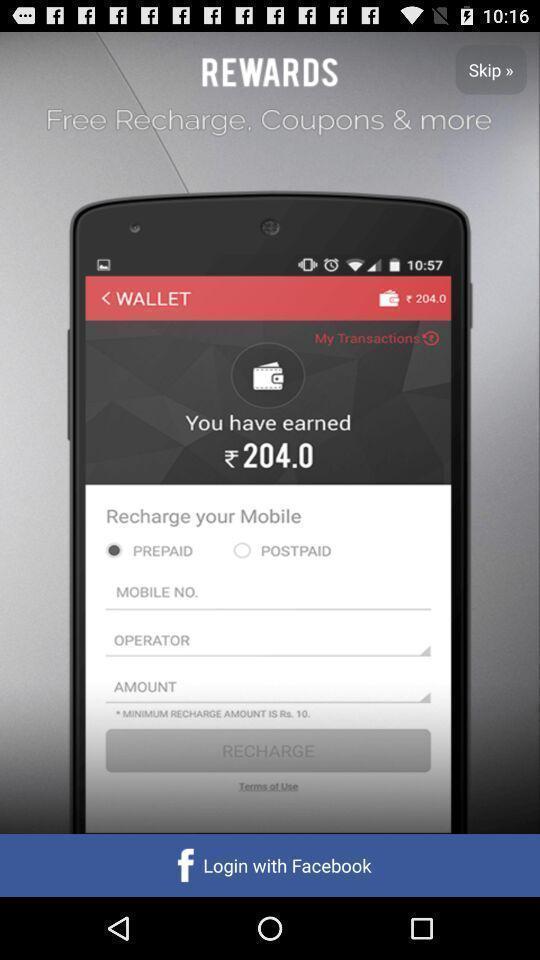Tell me what you see in this picture. Screen showing log in page. 